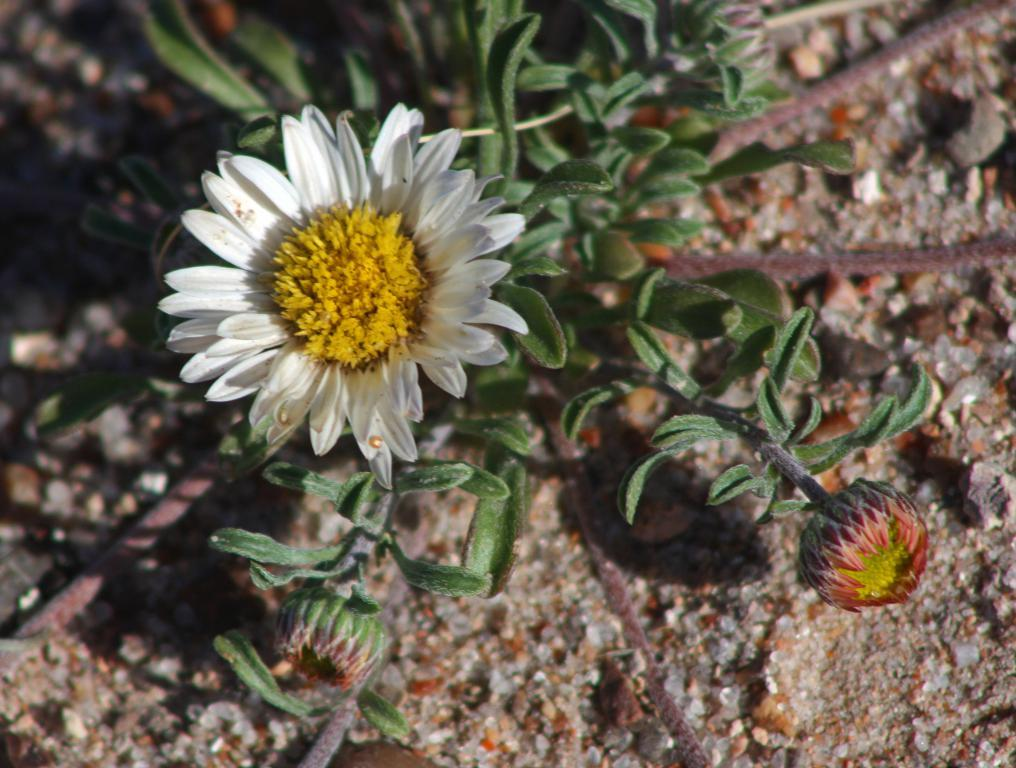What is present in the picture? There is a plant in the picture. How many flowers are on the plant? The plant has two flowers. What colors are the flowers? One flower is white in color, and the other flower is red in color. What is under the plant? There is a surface with stones under the plant. What type of waste is being disposed of near the plant in the image? There is no waste present in the image; it only features a plant with two flowers and a surface with stones underneath. 